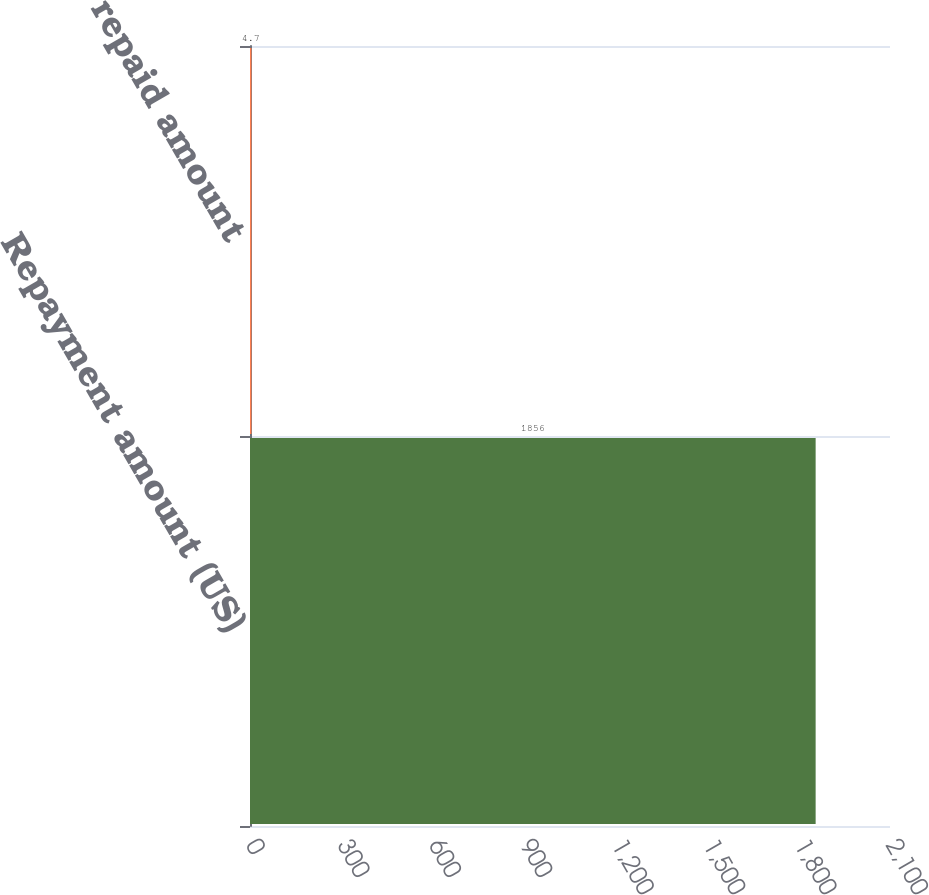<chart> <loc_0><loc_0><loc_500><loc_500><bar_chart><fcel>Repayment amount (US)<fcel>repaid amount<nl><fcel>1856<fcel>4.7<nl></chart> 